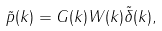<formula> <loc_0><loc_0><loc_500><loc_500>\tilde { p } ( { k } ) = { G } ( { k } ) W ( { k } ) \tilde { \delta } ( { k } ) ,</formula> 